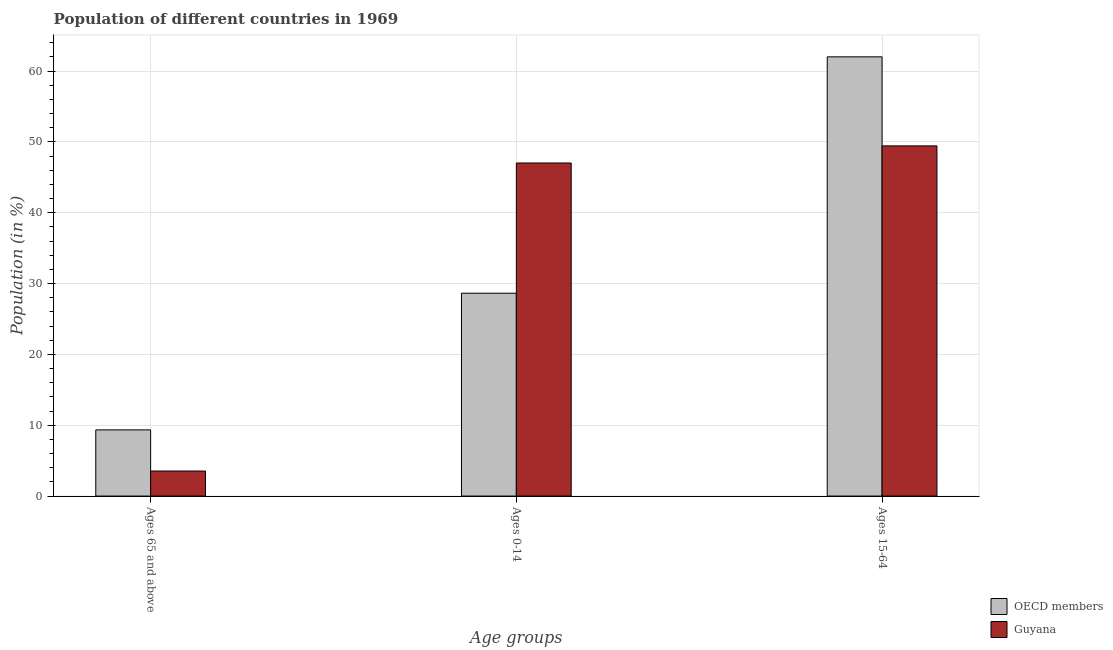Are the number of bars on each tick of the X-axis equal?
Provide a succinct answer. Yes. What is the label of the 3rd group of bars from the left?
Provide a succinct answer. Ages 15-64. What is the percentage of population within the age-group 15-64 in Guyana?
Your response must be concise. 49.44. Across all countries, what is the maximum percentage of population within the age-group 0-14?
Offer a terse response. 47.03. Across all countries, what is the minimum percentage of population within the age-group 0-14?
Provide a short and direct response. 28.64. In which country was the percentage of population within the age-group of 65 and above maximum?
Keep it short and to the point. OECD members. What is the total percentage of population within the age-group 15-64 in the graph?
Your answer should be compact. 111.45. What is the difference between the percentage of population within the age-group 15-64 in OECD members and that in Guyana?
Offer a very short reply. 12.57. What is the difference between the percentage of population within the age-group 0-14 in OECD members and the percentage of population within the age-group of 65 and above in Guyana?
Your answer should be compact. 25.11. What is the average percentage of population within the age-group 0-14 per country?
Your answer should be very brief. 37.83. What is the difference between the percentage of population within the age-group 15-64 and percentage of population within the age-group of 65 and above in OECD members?
Ensure brevity in your answer.  52.67. In how many countries, is the percentage of population within the age-group of 65 and above greater than 2 %?
Provide a short and direct response. 2. What is the ratio of the percentage of population within the age-group of 65 and above in Guyana to that in OECD members?
Your response must be concise. 0.38. Is the percentage of population within the age-group of 65 and above in Guyana less than that in OECD members?
Provide a succinct answer. Yes. Is the difference between the percentage of population within the age-group 0-14 in OECD members and Guyana greater than the difference between the percentage of population within the age-group 15-64 in OECD members and Guyana?
Give a very brief answer. No. What is the difference between the highest and the second highest percentage of population within the age-group of 65 and above?
Your response must be concise. 5.81. What is the difference between the highest and the lowest percentage of population within the age-group of 65 and above?
Offer a terse response. 5.81. In how many countries, is the percentage of population within the age-group of 65 and above greater than the average percentage of population within the age-group of 65 and above taken over all countries?
Offer a very short reply. 1. What does the 2nd bar from the left in Ages 0-14 represents?
Offer a terse response. Guyana. What does the 2nd bar from the right in Ages 15-64 represents?
Offer a very short reply. OECD members. Is it the case that in every country, the sum of the percentage of population within the age-group of 65 and above and percentage of population within the age-group 0-14 is greater than the percentage of population within the age-group 15-64?
Your answer should be very brief. No. Does the graph contain any zero values?
Give a very brief answer. No. Does the graph contain grids?
Offer a terse response. Yes. How many legend labels are there?
Ensure brevity in your answer.  2. What is the title of the graph?
Offer a terse response. Population of different countries in 1969. What is the label or title of the X-axis?
Provide a succinct answer. Age groups. What is the label or title of the Y-axis?
Ensure brevity in your answer.  Population (in %). What is the Population (in %) of OECD members in Ages 65 and above?
Your answer should be compact. 9.34. What is the Population (in %) in Guyana in Ages 65 and above?
Your answer should be very brief. 3.53. What is the Population (in %) of OECD members in Ages 0-14?
Ensure brevity in your answer.  28.64. What is the Population (in %) in Guyana in Ages 0-14?
Offer a terse response. 47.03. What is the Population (in %) in OECD members in Ages 15-64?
Give a very brief answer. 62.01. What is the Population (in %) in Guyana in Ages 15-64?
Your response must be concise. 49.44. Across all Age groups, what is the maximum Population (in %) in OECD members?
Make the answer very short. 62.01. Across all Age groups, what is the maximum Population (in %) in Guyana?
Ensure brevity in your answer.  49.44. Across all Age groups, what is the minimum Population (in %) in OECD members?
Provide a short and direct response. 9.34. Across all Age groups, what is the minimum Population (in %) in Guyana?
Your answer should be very brief. 3.53. What is the total Population (in %) in Guyana in the graph?
Your response must be concise. 100. What is the difference between the Population (in %) of OECD members in Ages 65 and above and that in Ages 0-14?
Give a very brief answer. -19.3. What is the difference between the Population (in %) in Guyana in Ages 65 and above and that in Ages 0-14?
Provide a short and direct response. -43.49. What is the difference between the Population (in %) in OECD members in Ages 65 and above and that in Ages 15-64?
Ensure brevity in your answer.  -52.67. What is the difference between the Population (in %) in Guyana in Ages 65 and above and that in Ages 15-64?
Your answer should be compact. -45.91. What is the difference between the Population (in %) of OECD members in Ages 0-14 and that in Ages 15-64?
Make the answer very short. -33.37. What is the difference between the Population (in %) in Guyana in Ages 0-14 and that in Ages 15-64?
Make the answer very short. -2.41. What is the difference between the Population (in %) in OECD members in Ages 65 and above and the Population (in %) in Guyana in Ages 0-14?
Keep it short and to the point. -37.68. What is the difference between the Population (in %) in OECD members in Ages 65 and above and the Population (in %) in Guyana in Ages 15-64?
Make the answer very short. -40.1. What is the difference between the Population (in %) in OECD members in Ages 0-14 and the Population (in %) in Guyana in Ages 15-64?
Offer a terse response. -20.8. What is the average Population (in %) of OECD members per Age groups?
Offer a terse response. 33.33. What is the average Population (in %) of Guyana per Age groups?
Your response must be concise. 33.33. What is the difference between the Population (in %) of OECD members and Population (in %) of Guyana in Ages 65 and above?
Your response must be concise. 5.81. What is the difference between the Population (in %) of OECD members and Population (in %) of Guyana in Ages 0-14?
Give a very brief answer. -18.39. What is the difference between the Population (in %) of OECD members and Population (in %) of Guyana in Ages 15-64?
Keep it short and to the point. 12.57. What is the ratio of the Population (in %) in OECD members in Ages 65 and above to that in Ages 0-14?
Your answer should be compact. 0.33. What is the ratio of the Population (in %) in Guyana in Ages 65 and above to that in Ages 0-14?
Offer a very short reply. 0.08. What is the ratio of the Population (in %) of OECD members in Ages 65 and above to that in Ages 15-64?
Your answer should be very brief. 0.15. What is the ratio of the Population (in %) in Guyana in Ages 65 and above to that in Ages 15-64?
Keep it short and to the point. 0.07. What is the ratio of the Population (in %) of OECD members in Ages 0-14 to that in Ages 15-64?
Offer a very short reply. 0.46. What is the ratio of the Population (in %) of Guyana in Ages 0-14 to that in Ages 15-64?
Your answer should be compact. 0.95. What is the difference between the highest and the second highest Population (in %) in OECD members?
Provide a short and direct response. 33.37. What is the difference between the highest and the second highest Population (in %) of Guyana?
Make the answer very short. 2.41. What is the difference between the highest and the lowest Population (in %) in OECD members?
Your answer should be compact. 52.67. What is the difference between the highest and the lowest Population (in %) in Guyana?
Offer a terse response. 45.91. 